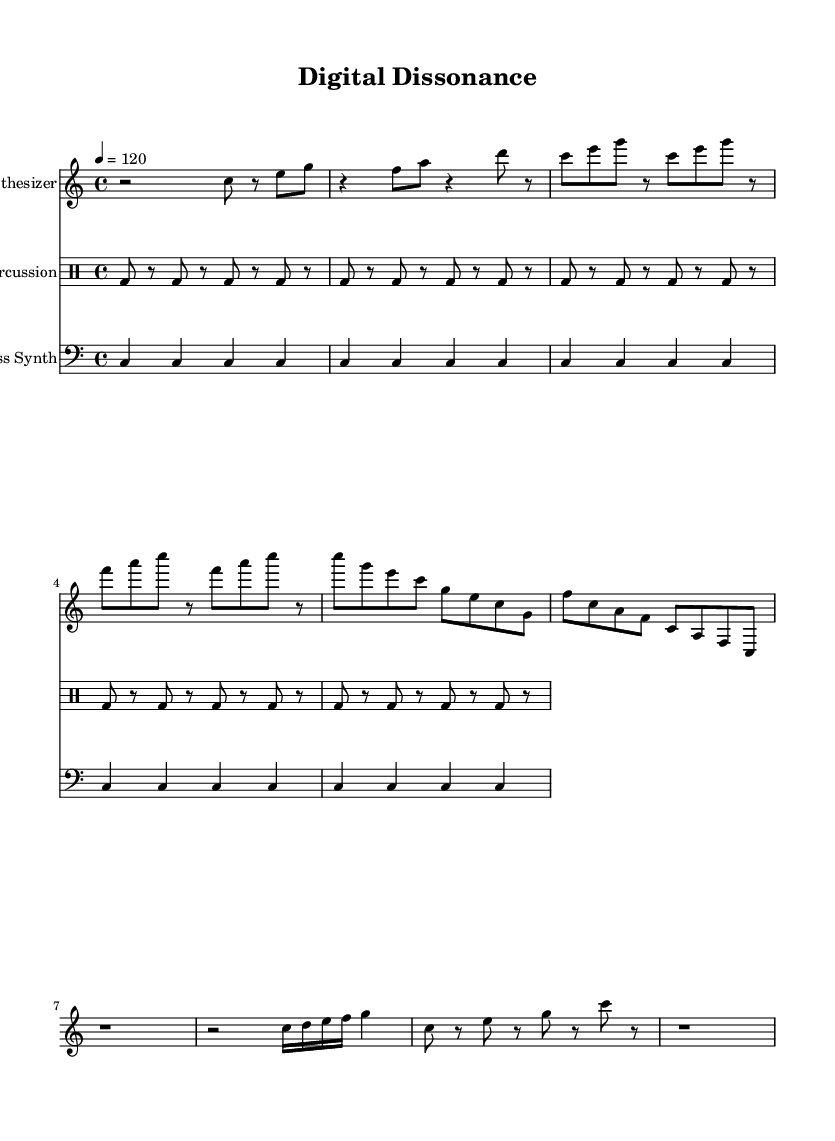What is the key signature of this music? The key signature indicates that this piece is in C major, which has no sharps or flats. This can be seen at the beginning of the score where the key signature is marked.
Answer: C major What is the time signature of this music? The time signature is found at the beginning and indicates that the piece is in 4/4 time, which means there are four beats in each measure. This is clearly stated at the start of the sheet music.
Answer: 4/4 What is the tempo marking of this music? The tempo marking is found at the beginning of the score, which indicates the speed of the piece. It states "4 = 120," meaning there are 120 beats per minute.
Answer: 120 How many measures are there in the synthesizer part? To find the number of measures, we can count the individual measures in the synthesizer part. Upon counting, there are 8 measures in total in the synthesizer section.
Answer: 8 What type of rhythmic pattern is used in the glitch percussion? The glitch percussion part primarily features a consistent bass drum pattern of eighth notes with rests. This is recognizable by the rhythmic structure repeated throughout the score.
Answer: Eighth notes What is the primary function of the bass synth in this piece? The bass synth provides a constant foundation by playing sustained notes, maintaining the harmonic and rhythmic base of the composition. Its repetitive nature supports the other elements of the music.
Answer: Foundation How does the glitch percussion contribute to the overall feel of the piece? The glitch percussion adds irregularities and unexpected pauses, creating a sense of unpredictability and tension that aligns with the experimental nature of the composition. It contrasts with the more melodic synthesizer and bass synth parts.
Answer: Unpredictability 